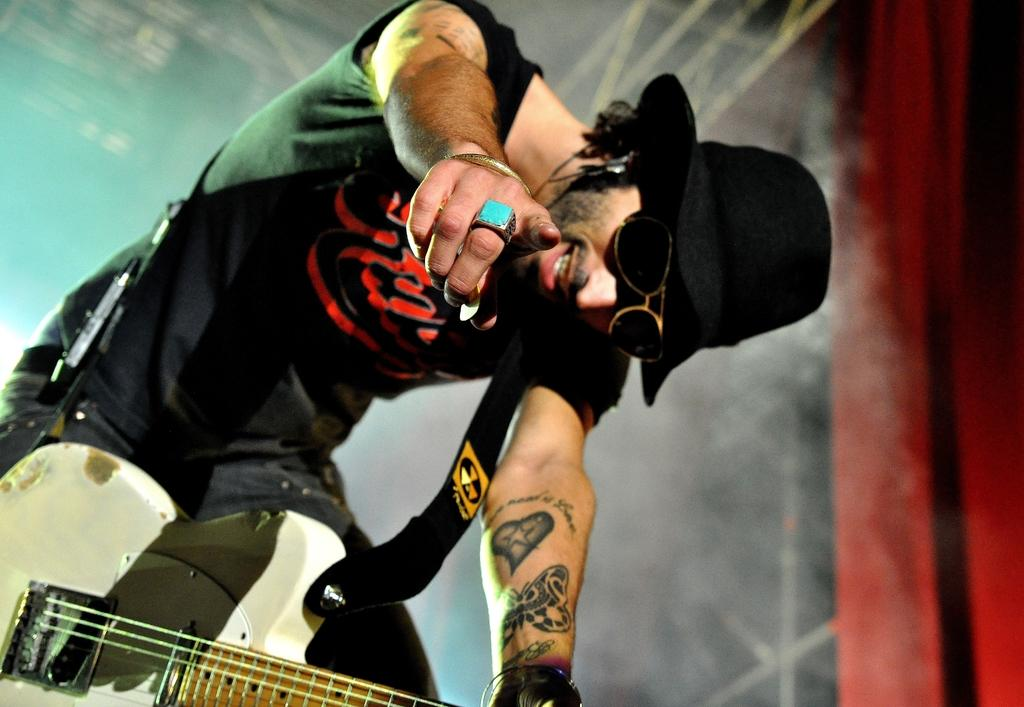What is the main subject of the picture? The main subject of the picture is a man. What is the man doing in the picture? The man is standing in the picture. What object is the man holding in the picture? The man is holding a guitar in the picture. What type of bean is growing in the man's beard in the image? There is no bean growing in the man's beard in the image. 